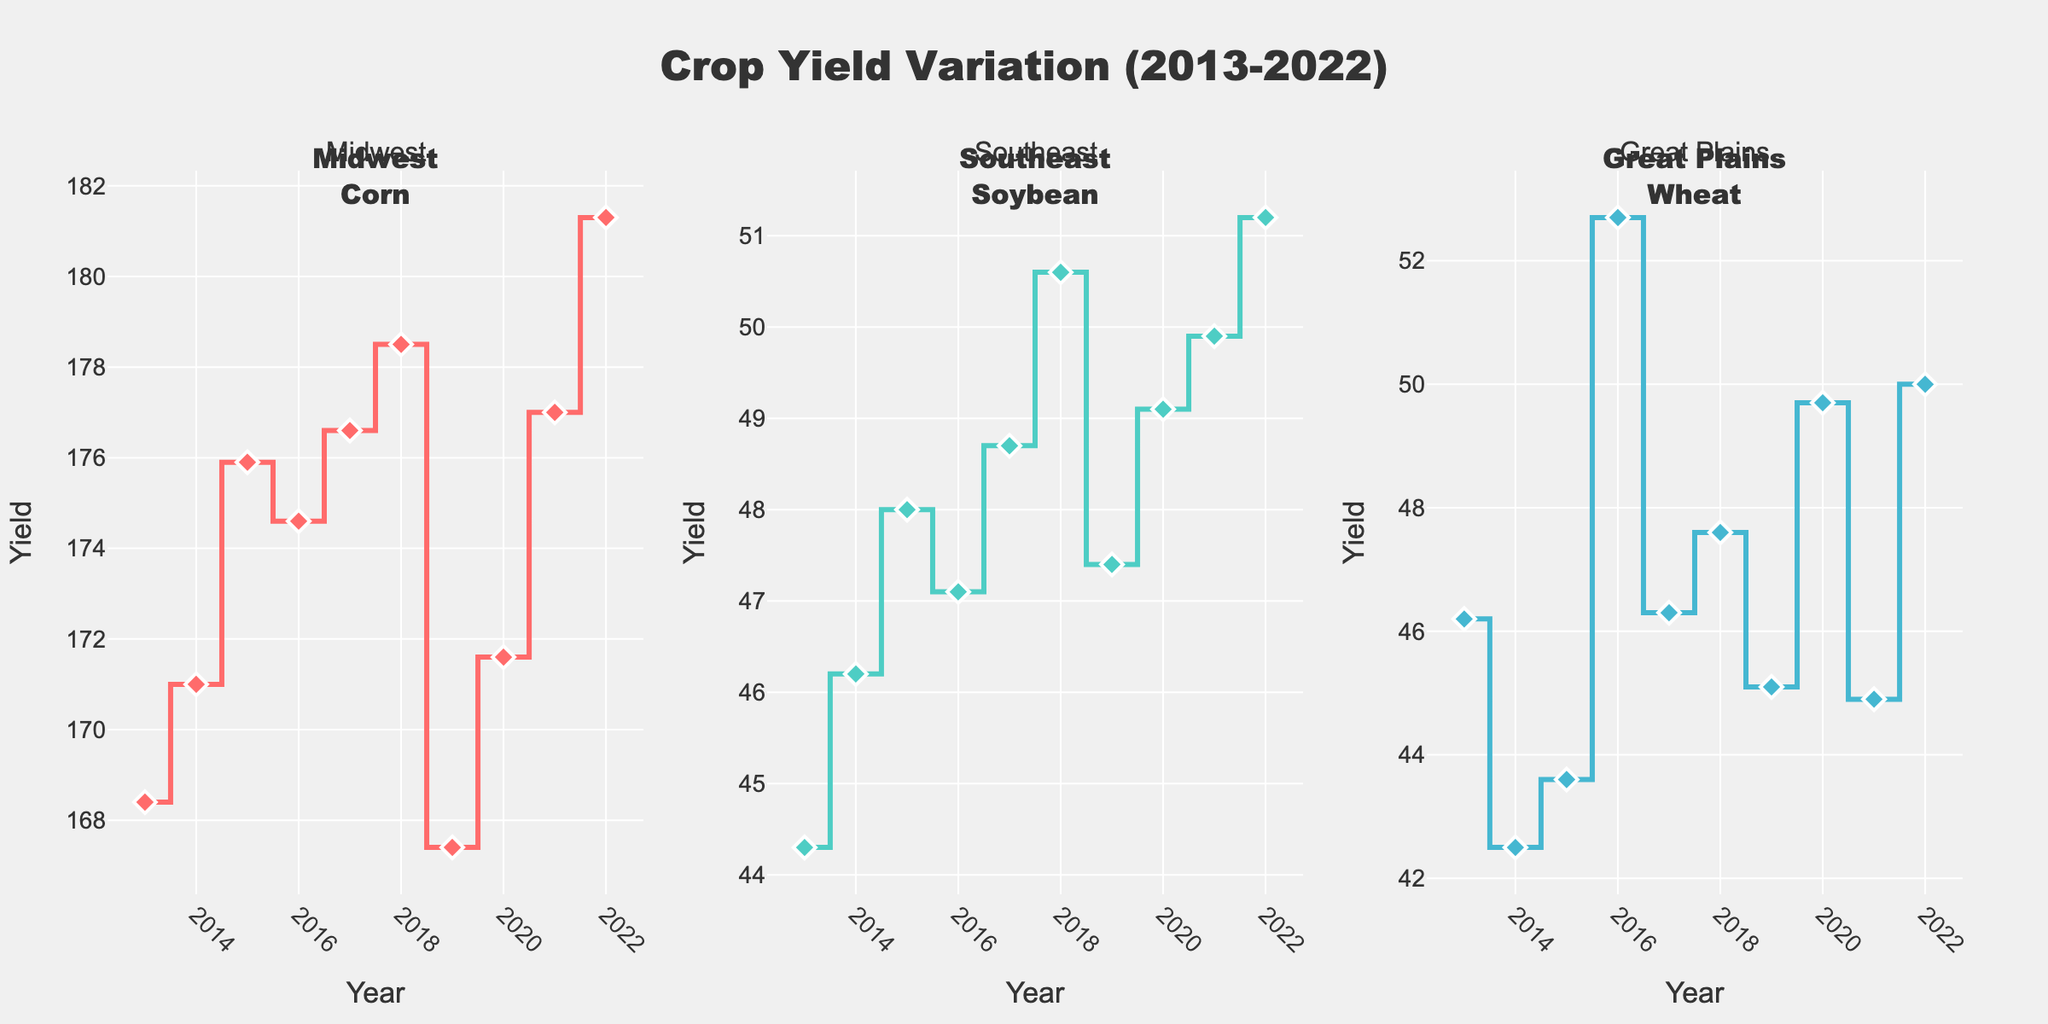What is the overall title of the figure? The title of the figure is usually displayed at the top of the plot, prominently in larger text.
Answer: Crop Yield Variation (2013-2022) Which region has the highest crop yield in 2022? Look at the year 2022 for all three subplots and compare the yield values. Midwest (Corn) has a yield of 181.3, Southeast (Soybean) 51.2, and Great Plains (Wheat) 50.0.
Answer: Midwest What crop is represented for the Southeast region? The Southeast subplot title will mention "Soybean", also seen in the annotations.
Answer: Soybean What is the yield trend for Corn in the Midwest between 2013 and 2022? Observe the line trajectory in the Midwest subplot from 2013 to 2022, it generally shows an increasing trend with slight fluctuations.
Answer: Increasing trend Which year had the lowest yield for Wheat in the Great Plains? In the Great Plains subplot, identify the year with the lowest point; the year is 2014 with a yield of 42.5.
Answer: 2014 Compare the yield of Soybean in the Southeast in 2015 and 2018. Check the precise values for 2015 and 2018 in the Southeast subplot, 48.0 for 2015 and 50.6 for 2018.
Answer: 2018 had higher yield What's the average yield of Corn in the Midwest from 2013 to 2022? Sum the yield values from 2013 to 2022 in the Midwest: (168.4 + 171.0 + 175.9 + 174.6 + 176.6 + 178.5 + 167.4 + 171.6 + 177.0 + 181.3) = 1742.3. Divide by 10 years: 1742.3 / 10 = 174.2.
Answer: 174.2 What is the median yield value for Wheat in the Great Plains? Arrange the wheat yields in ascending order: 42.5, 43.6, 44.9, 45.1, 46.2, 46.3, 47.6, 49.7, 50.0, 52.7. As there are 10 values, the median is the average of the 5th and 6th values (46.2+46.3)/2 = 46.25.
Answer: 46.25 Between 2019 and 2020, which region showed an increase in yield? Compare the yields of 2019 and 2020 for each region: Midwest (167.4 to 171.6), Southeast (47.4 to 49.1), Great Plains (45.1 to 49.7); all regions showed an increase.
Answer: All regions Identify any year where all three regions had a decreasing trend compared to the previous year. Look at the yield values year-over-year for a declining pattern. In 2019, Midwest decreased from 178.5 to 167.4, Southeast decreased from 50.6 to 47.4, and Great Plains decreased from 47.6 to 45.1.
Answer: 2019 